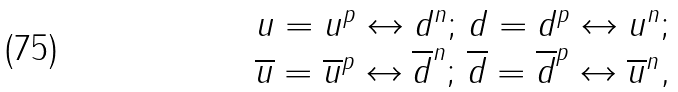<formula> <loc_0><loc_0><loc_500><loc_500>\begin{array} { c l c r } u = u ^ { p } \leftrightarrow d ^ { n } ; \, d = d ^ { p } \leftrightarrow u ^ { n } ; \\ \overline { u } = \overline { u } ^ { p } \leftrightarrow \overline { d } ^ { n } ; \, \overline { d } = \overline { d } ^ { p } \leftrightarrow \overline { u } ^ { n } , \end{array}</formula> 